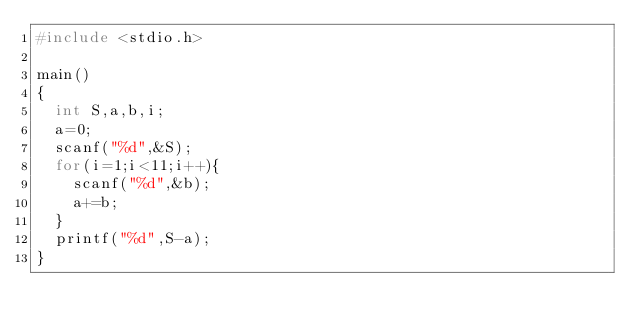<code> <loc_0><loc_0><loc_500><loc_500><_C++_>#include <stdio.h>

main()
{
	int S,a,b,i;
	a=0;
	scanf("%d",&S);
	for(i=1;i<11;i++){
		scanf("%d",&b);
		a+=b;
	}
	printf("%d",S-a);
}</code> 